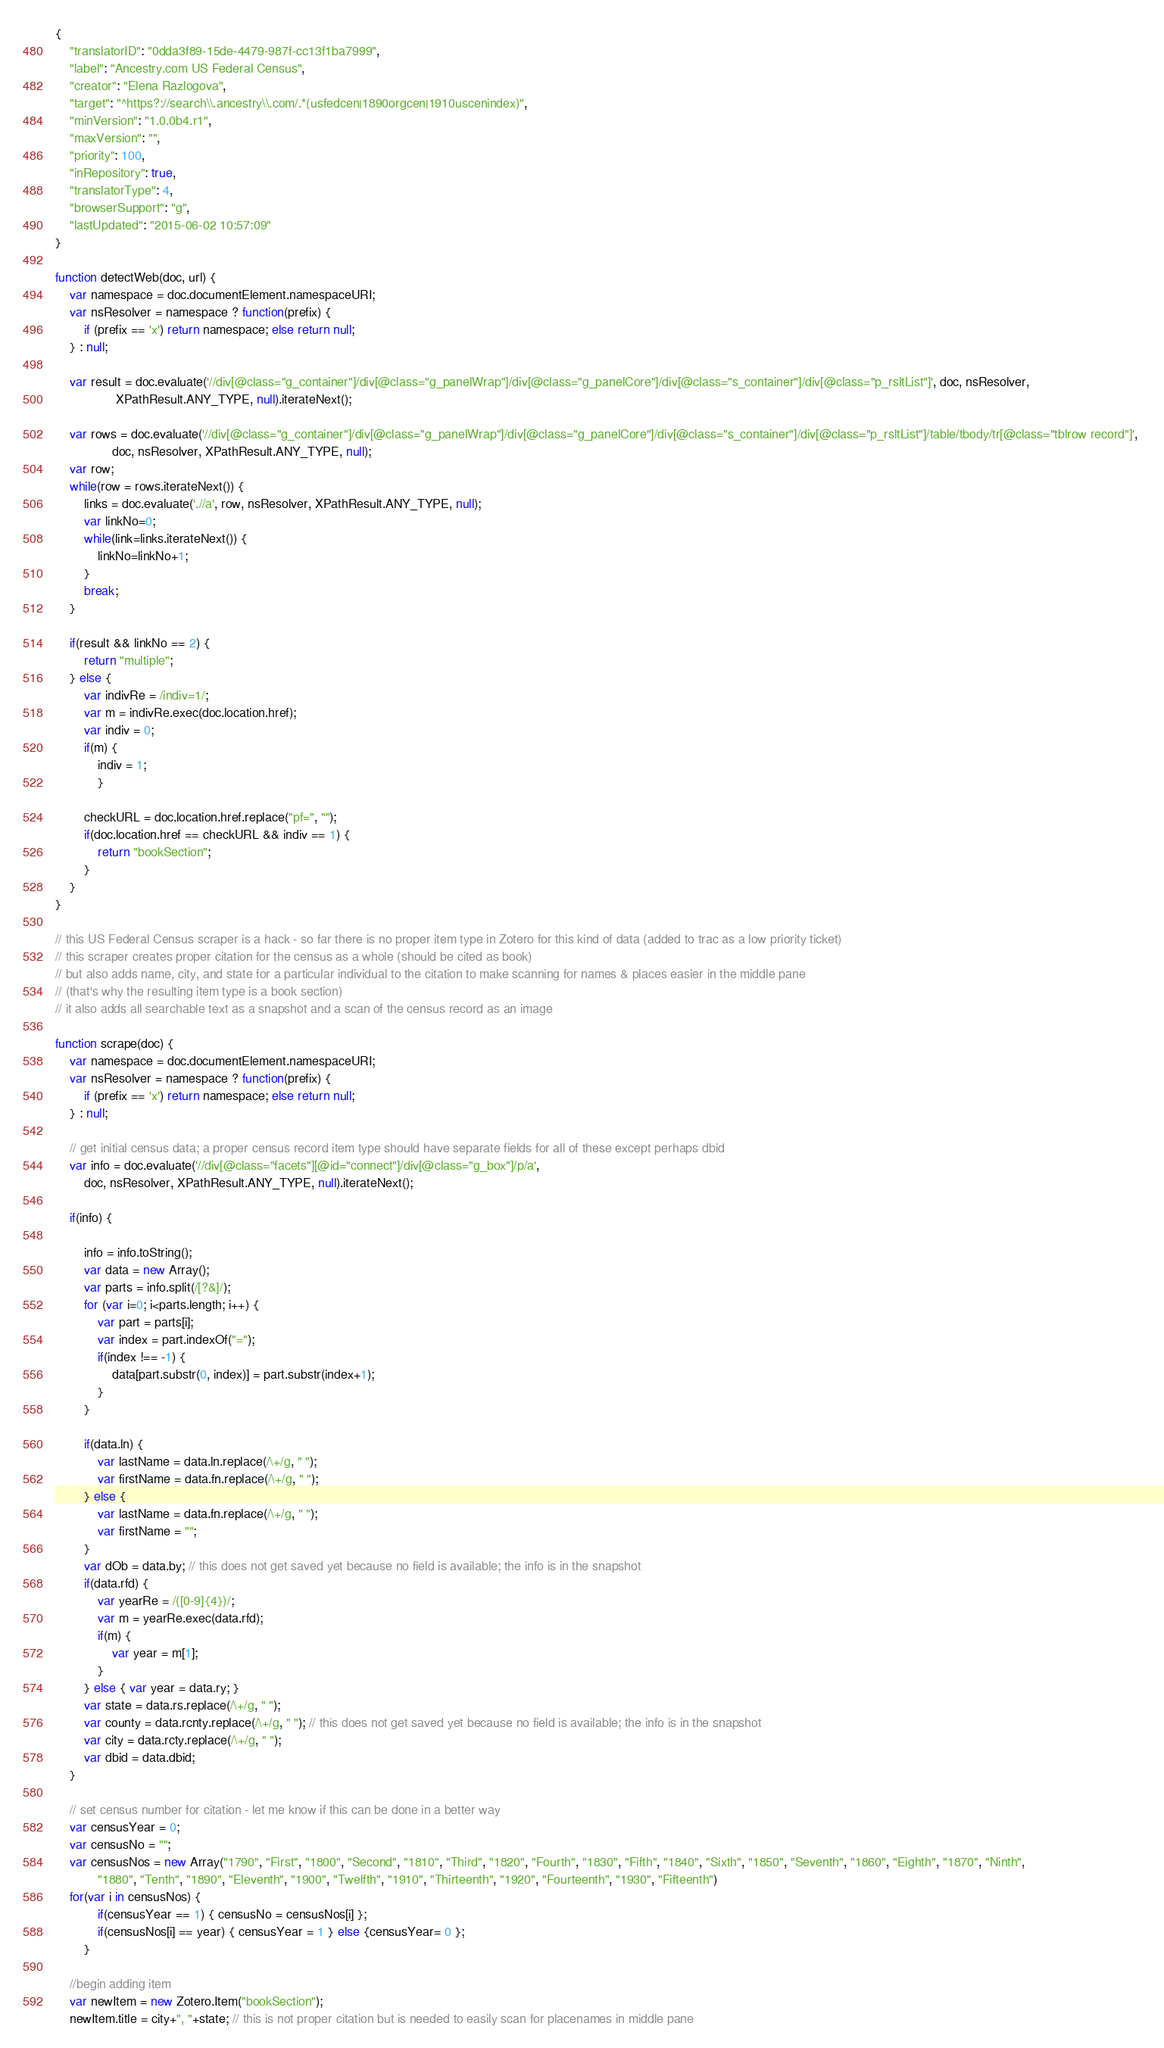<code> <loc_0><loc_0><loc_500><loc_500><_JavaScript_>{
	"translatorID": "0dda3f89-15de-4479-987f-cc13f1ba7999",
	"label": "Ancestry.com US Federal Census",
	"creator": "Elena Razlogova",
	"target": "^https?://search\\.ancestry\\.com/.*(usfedcen|1890orgcen|1910uscenindex)",
	"minVersion": "1.0.0b4.r1",
	"maxVersion": "",
	"priority": 100,
	"inRepository": true,
	"translatorType": 4,
	"browserSupport": "g",
	"lastUpdated": "2015-06-02 10:57:09"
}

function detectWeb(doc, url) {
	var namespace = doc.documentElement.namespaceURI;
	var nsResolver = namespace ? function(prefix) {
		if (prefix == 'x') return namespace; else return null;
	} : null;
		
	var result = doc.evaluate('//div[@class="g_container"]/div[@class="g_panelWrap"]/div[@class="g_panelCore"]/div[@class="s_container"]/div[@class="p_rsltList"]', doc, nsResolver,
	             XPathResult.ANY_TYPE, null).iterateNext();

	var rows = doc.evaluate('//div[@class="g_container"]/div[@class="g_panelWrap"]/div[@class="g_panelCore"]/div[@class="s_container"]/div[@class="p_rsltList"]/table/tbody/tr[@class="tblrow record"]', 
				doc, nsResolver, XPathResult.ANY_TYPE, null);
	var row;
	while(row = rows.iterateNext()) {
		links = doc.evaluate('.//a', row, nsResolver, XPathResult.ANY_TYPE, null);
		var linkNo=0;
		while(link=links.iterateNext()) {
			linkNo=linkNo+1;
		}
		break;
	}
	
	if(result && linkNo == 2) {
		return "multiple";
	} else {
		var indivRe = /indiv=1/;
		var m = indivRe.exec(doc.location.href);
		var indiv = 0;
		if(m) {
			indiv = 1;
			}

		checkURL = doc.location.href.replace("pf=", "");
		if(doc.location.href == checkURL && indiv == 1) {
			return "bookSection";
		}
	} 
}

// this US Federal Census scraper is a hack - so far there is no proper item type in Zotero for this kind of data (added to trac as a low priority ticket)
// this scraper creates proper citation for the census as a whole (should be cited as book)
// but also adds name, city, and state for a particular individual to the citation to make scanning for names & places easier in the middle pane 
// (that's why the resulting item type is a book section) 
// it also adds all searchable text as a snapshot and a scan of the census record as an image

function scrape(doc) {
	var namespace = doc.documentElement.namespaceURI;
	var nsResolver = namespace ? function(prefix) {
		if (prefix == 'x') return namespace; else return null;
	} : null;
	
	// get initial census data; a proper census record item type should have separate fields for all of these except perhaps dbid
	var info = doc.evaluate('//div[@class="facets"][@id="connect"]/div[@class="g_box"]/p/a', 
		doc, nsResolver, XPathResult.ANY_TYPE, null).iterateNext();	
		
	if(info) {	
		
		info = info.toString();
		var data = new Array();
		var parts = info.split(/[?&]/);
		for (var i=0; i<parts.length; i++) {
			var part = parts[i];
			var index = part.indexOf("=");
			if(index !== -1) {
				data[part.substr(0, index)] = part.substr(index+1);
			}
		}
		
		if(data.ln) {
			var lastName = data.ln.replace(/\+/g, " ");
			var firstName = data.fn.replace(/\+/g, " ");
		} else { 
			var lastName = data.fn.replace(/\+/g, " ");
			var firstName = ""; 
		}
		var dOb = data.by; // this does not get saved yet because no field is available; the info is in the snapshot
		if(data.rfd) {
			var yearRe = /([0-9]{4})/;
			var m = yearRe.exec(data.rfd);
			if(m) { 
				var year = m[1];
			}
		} else { var year = data.ry; }
		var state = data.rs.replace(/\+/g, " "); 
		var county = data.rcnty.replace(/\+/g, " "); // this does not get saved yet because no field is available; the info is in the snapshot
		var city = data.rcty.replace(/\+/g, " "); 
		var dbid = data.dbid;
	}
	
	// set census number for citation - let me know if this can be done in a better way
	var censusYear = 0;
	var censusNo = "";
	var censusNos = new Array("1790", "First", "1800", "Second", "1810", "Third", "1820", "Fourth", "1830", "Fifth", "1840", "Sixth", "1850", "Seventh", "1860", "Eighth", "1870", "Ninth", 
			"1880", "Tenth", "1890", "Eleventh", "1900", "Twelfth", "1910", "Thirteenth", "1920", "Fourteenth", "1930", "Fifteenth")
	for(var i in censusNos) {
			if(censusYear == 1) { censusNo = censusNos[i] };
			if(censusNos[i] == year) { censusYear = 1 } else {censusYear= 0 };
		}

	//begin adding item
	var newItem = new Zotero.Item("bookSection");
	newItem.title = city+", "+state; // this is not proper citation but is needed to easily scan for placenames in middle pane</code> 